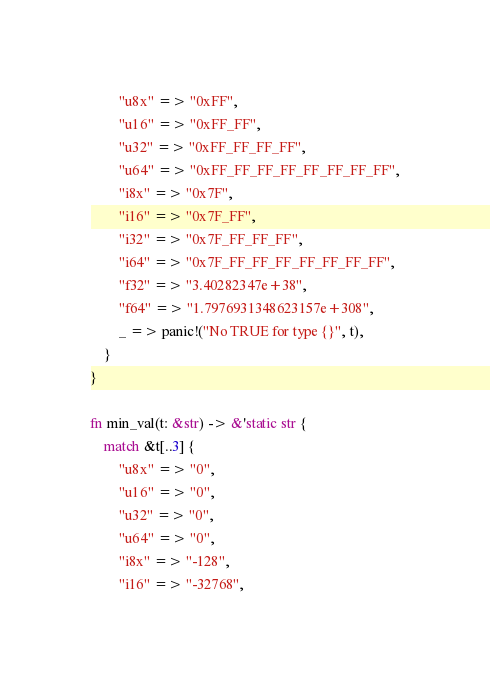<code> <loc_0><loc_0><loc_500><loc_500><_Rust_>        "u8x" => "0xFF",
        "u16" => "0xFF_FF",
        "u32" => "0xFF_FF_FF_FF",
        "u64" => "0xFF_FF_FF_FF_FF_FF_FF_FF",
        "i8x" => "0x7F",
        "i16" => "0x7F_FF",
        "i32" => "0x7F_FF_FF_FF",
        "i64" => "0x7F_FF_FF_FF_FF_FF_FF_FF",
        "f32" => "3.40282347e+38",
        "f64" => "1.7976931348623157e+308",
        _ => panic!("No TRUE for type {}", t),
    }
}

fn min_val(t: &str) -> &'static str {
    match &t[..3] {
        "u8x" => "0",
        "u16" => "0",
        "u32" => "0",
        "u64" => "0",
        "i8x" => "-128",
        "i16" => "-32768",</code> 